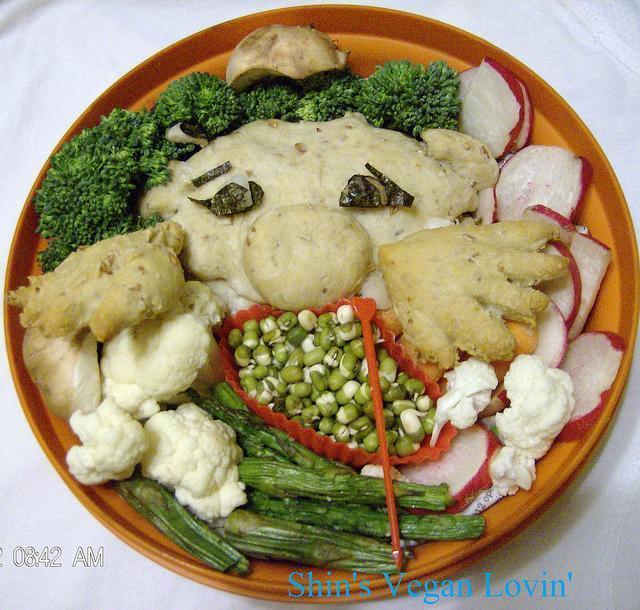How many broccolis are there?
Give a very brief answer. 2. 